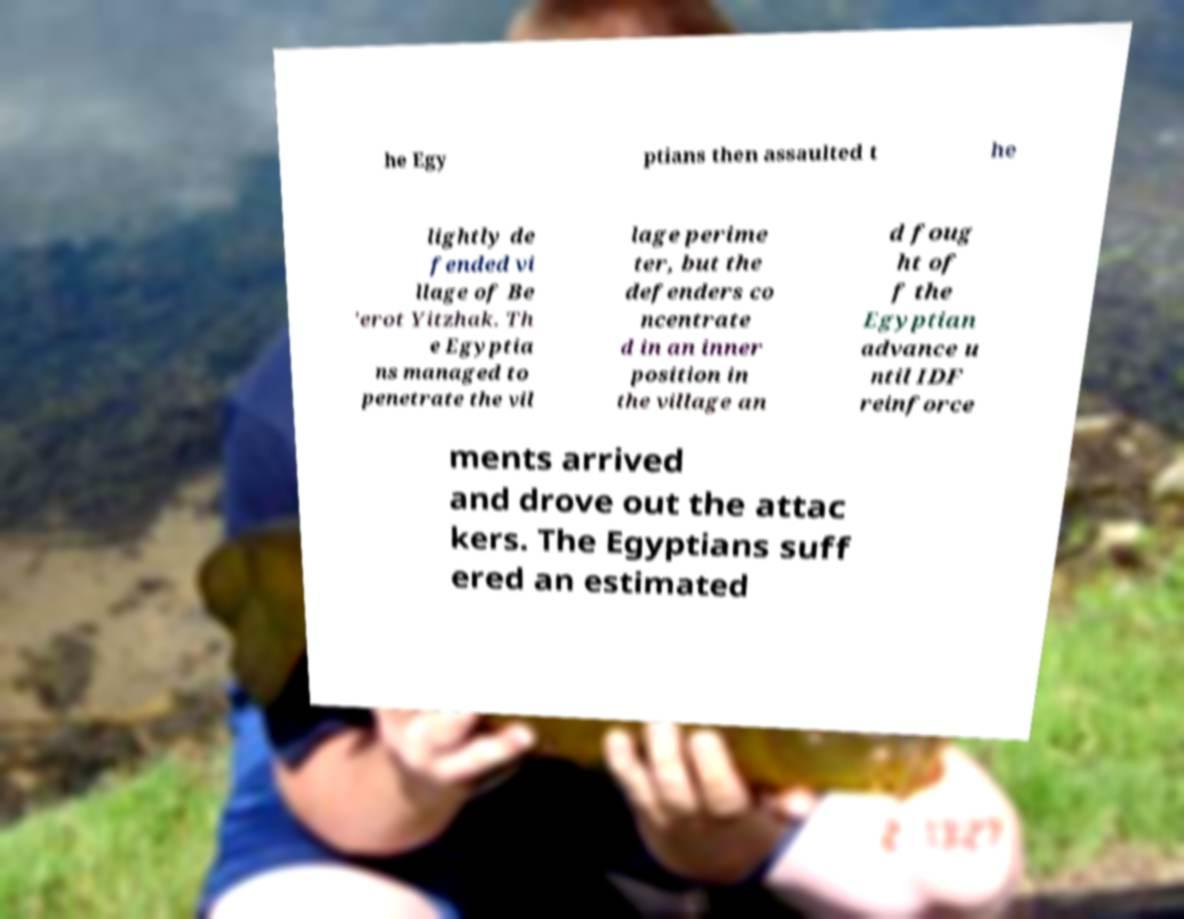Please read and relay the text visible in this image. What does it say? he Egy ptians then assaulted t he lightly de fended vi llage of Be 'erot Yitzhak. Th e Egyptia ns managed to penetrate the vil lage perime ter, but the defenders co ncentrate d in an inner position in the village an d foug ht of f the Egyptian advance u ntil IDF reinforce ments arrived and drove out the attac kers. The Egyptians suff ered an estimated 